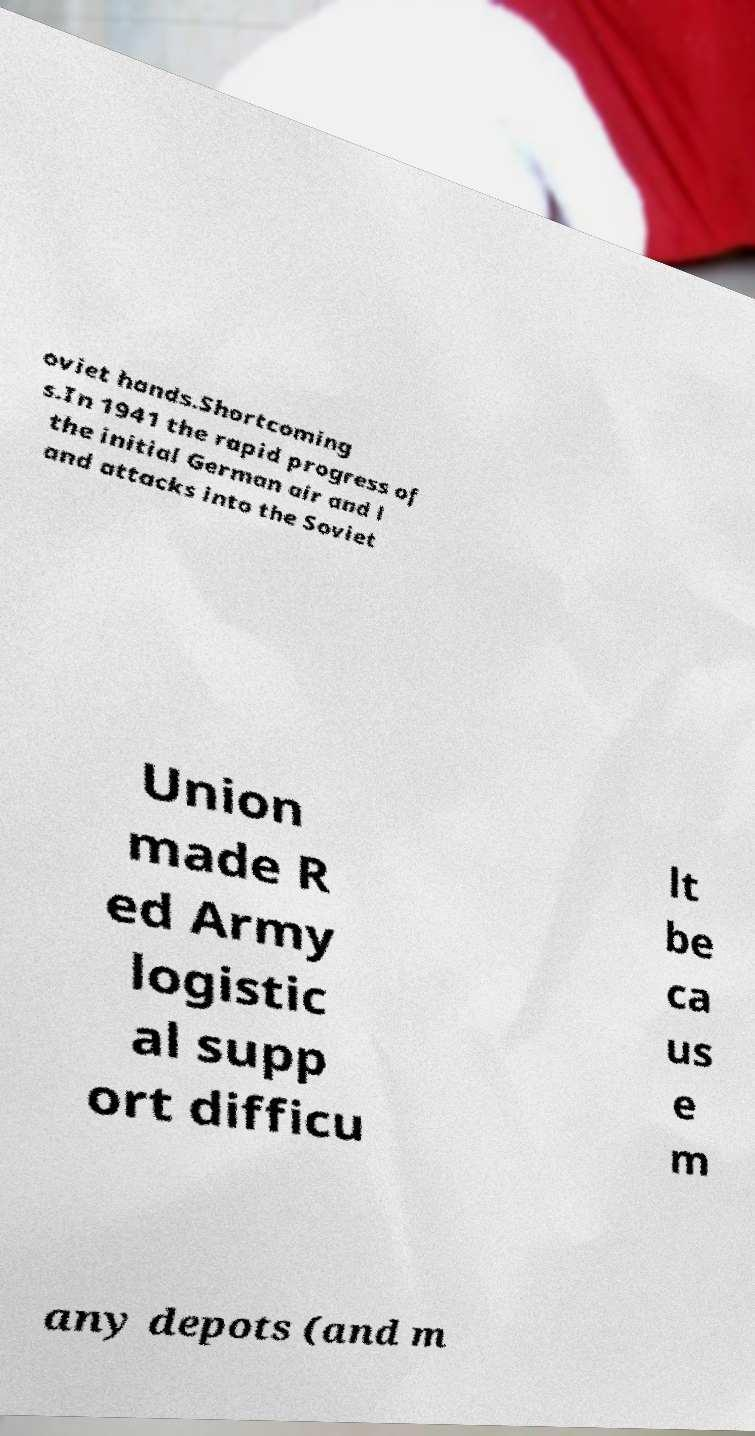There's text embedded in this image that I need extracted. Can you transcribe it verbatim? oviet hands.Shortcoming s.In 1941 the rapid progress of the initial German air and l and attacks into the Soviet Union made R ed Army logistic al supp ort difficu lt be ca us e m any depots (and m 